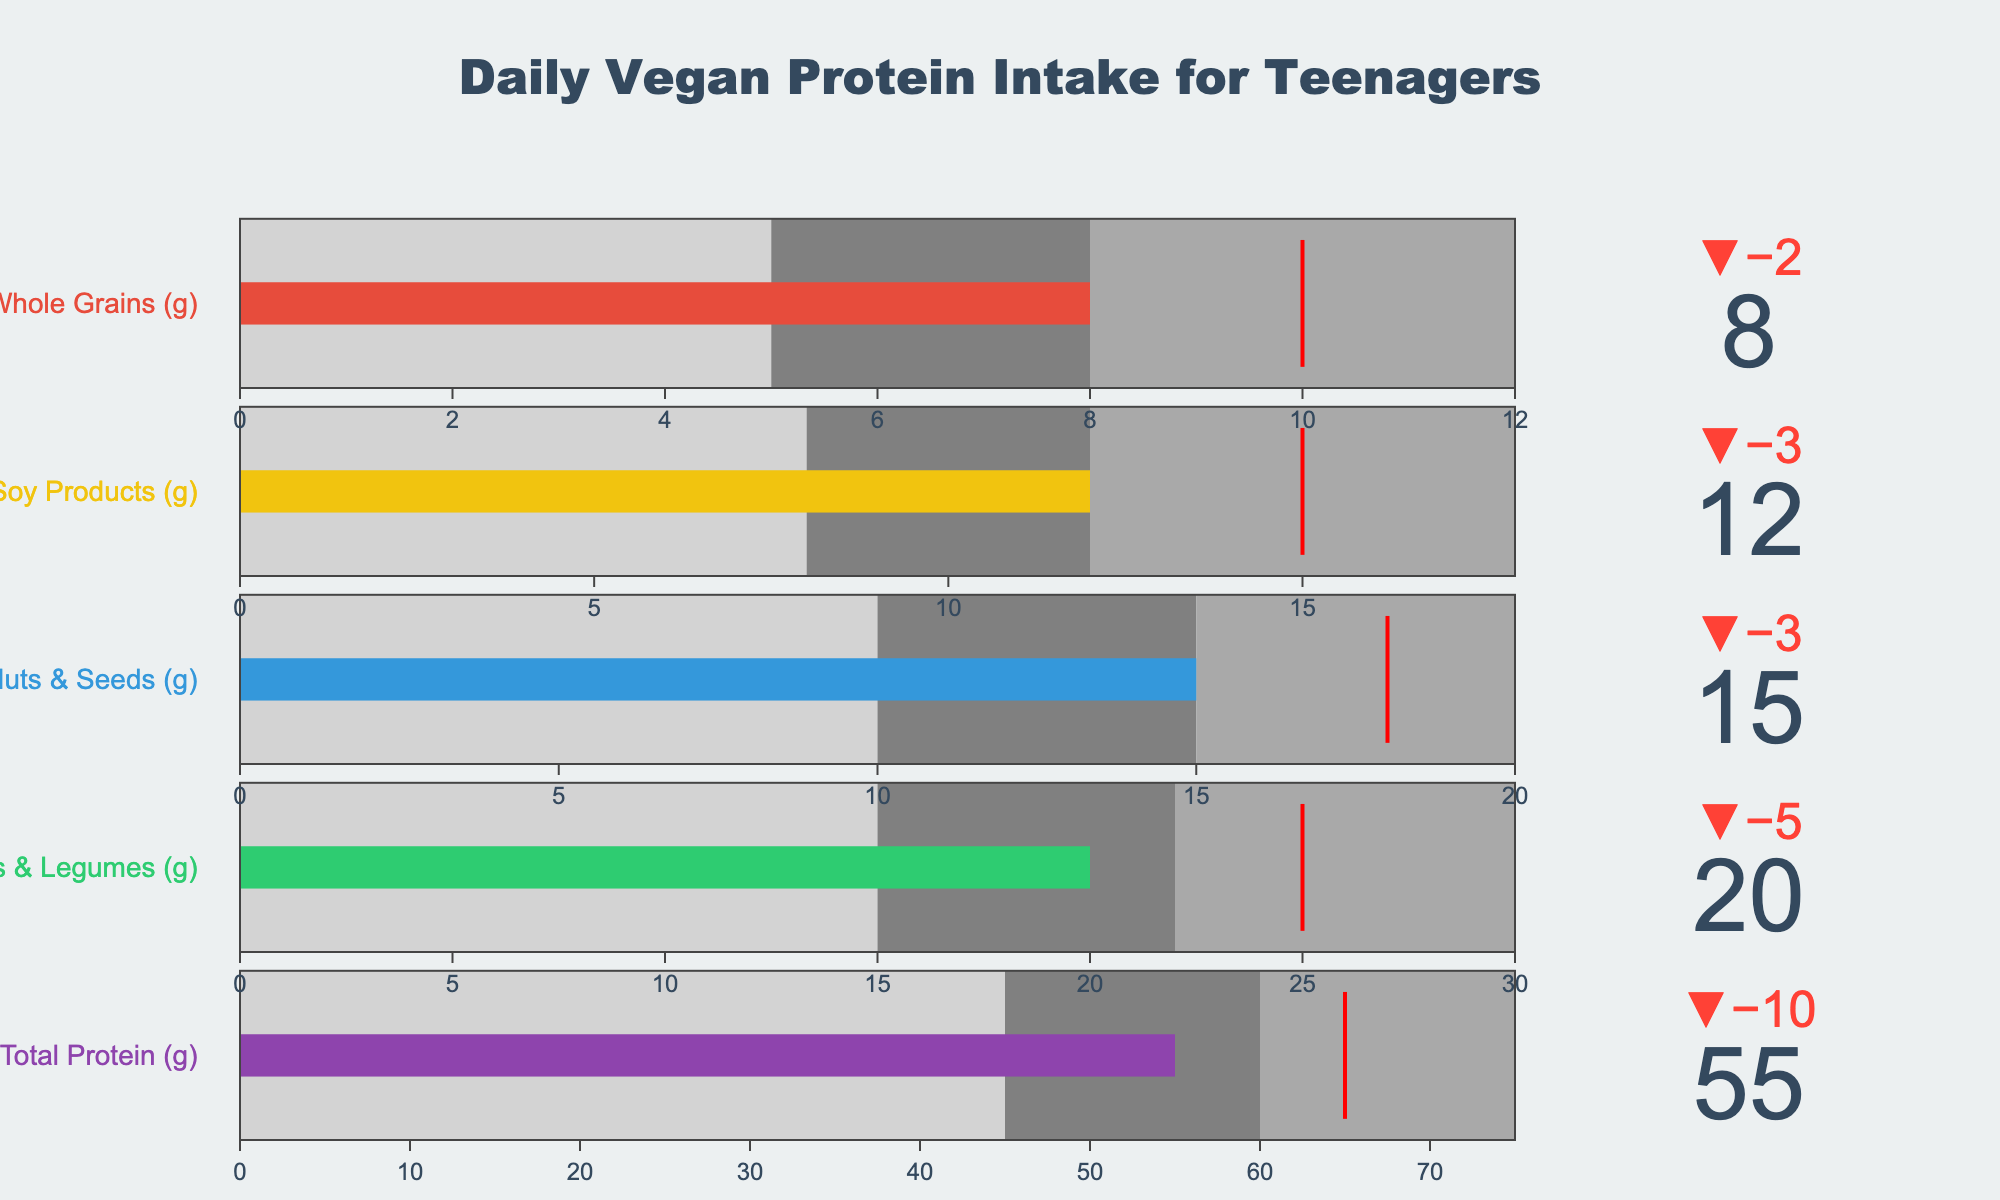What's the title of the chart? The title is located at the top center of the chart. It reads "Daily Vegan Protein Intake for Teenagers."
Answer: Daily Vegan Protein Intake for Teenagers What are the actual protein intakes of beans & legumes and nuts & seeds combined? The actual intakes for beans & legumes and nuts & seeds are 20g and 15g respectively. Adding them together gives 20 + 15 = 35 grams.
Answer: 35 grams How does the actual intake of soy products compare to its target? The actual intake of soy products is 12g, which is less than the target of 15g.
Answer: Less than the target Which category has the highest actual protein intake? By comparing the actual intakes across categories, the 'Total Protein' category has the highest value at 55 grams.
Answer: Total Protein Is the actual intake of whole grains within the medium range? The medium range for whole grains is between 8g and 12g. The actual intake is 8g, which falls within this range.
Answer: Yes What is the total target protein intake for all categories combined? The target intakes for all categories are: Total Protein (65g), Beans & Legumes (25g), Nuts & Seeds (18g), Soy Products (15g), Whole Grains (10g). Summing these gives 65 + 25 + 18 + 15 + 10 = 133 grams.
Answer: 133 grams By how much does the actual intake of total protein fall short of the target? The target for total protein is 65g and the actual intake is 55g. The shortfall is 65 - 55 = 10 grams.
Answer: 10 grams Which category has the smallest difference between actual intake and target? By observing the deltas, the category with the smallest difference is 'Whole Grains', with both actual and target values at 8g and 10g respectively.
Answer: Whole Grains 